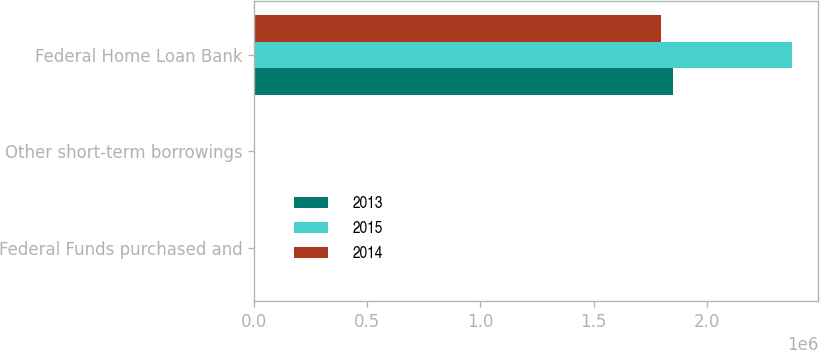Convert chart. <chart><loc_0><loc_0><loc_500><loc_500><stacked_bar_chart><ecel><fcel>Federal Funds purchased and<fcel>Other short-term borrowings<fcel>Federal Home Loan Bank<nl><fcel>2013<fcel>0.13<fcel>0.27<fcel>1.85e+06<nl><fcel>2015<fcel>0.08<fcel>1.11<fcel>2.375e+06<nl><fcel>2014<fcel>0.06<fcel>2.59<fcel>1.8e+06<nl></chart> 